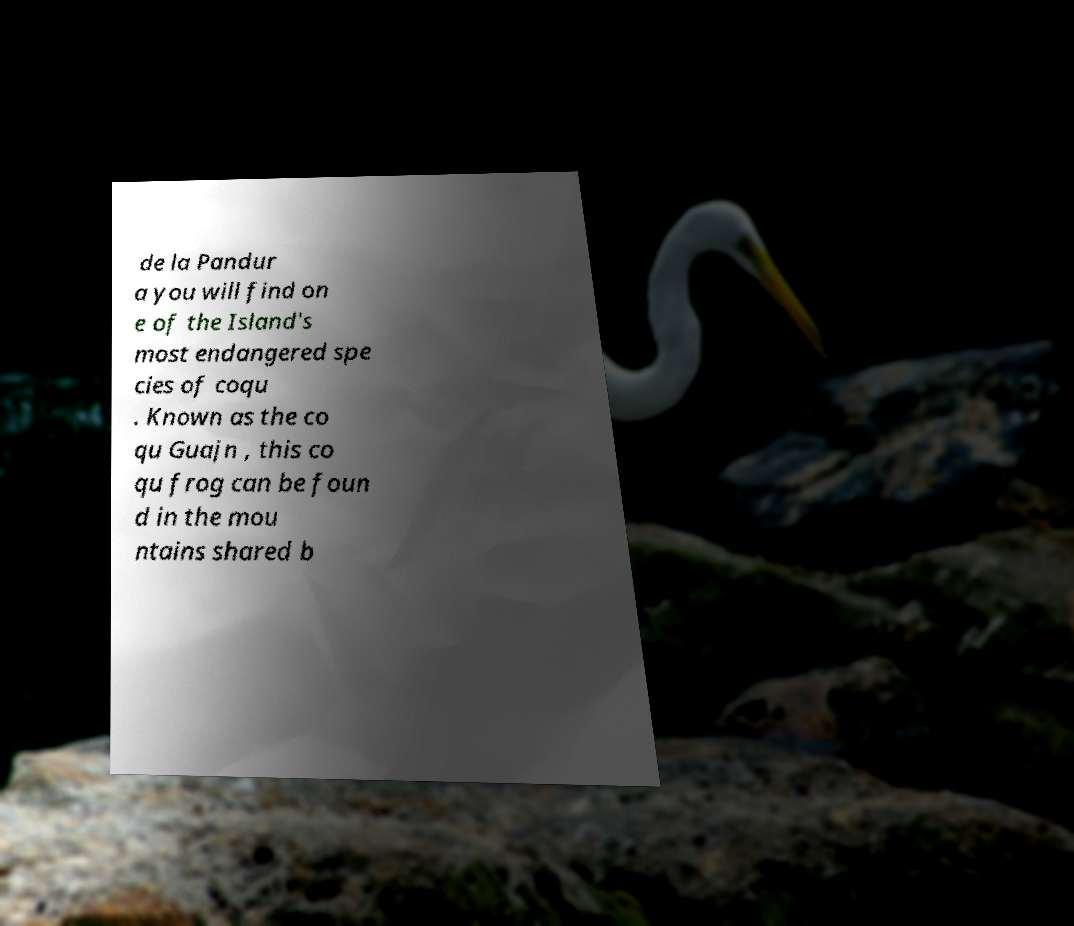Please identify and transcribe the text found in this image. de la Pandur a you will find on e of the Island's most endangered spe cies of coqu . Known as the co qu Guajn , this co qu frog can be foun d in the mou ntains shared b 